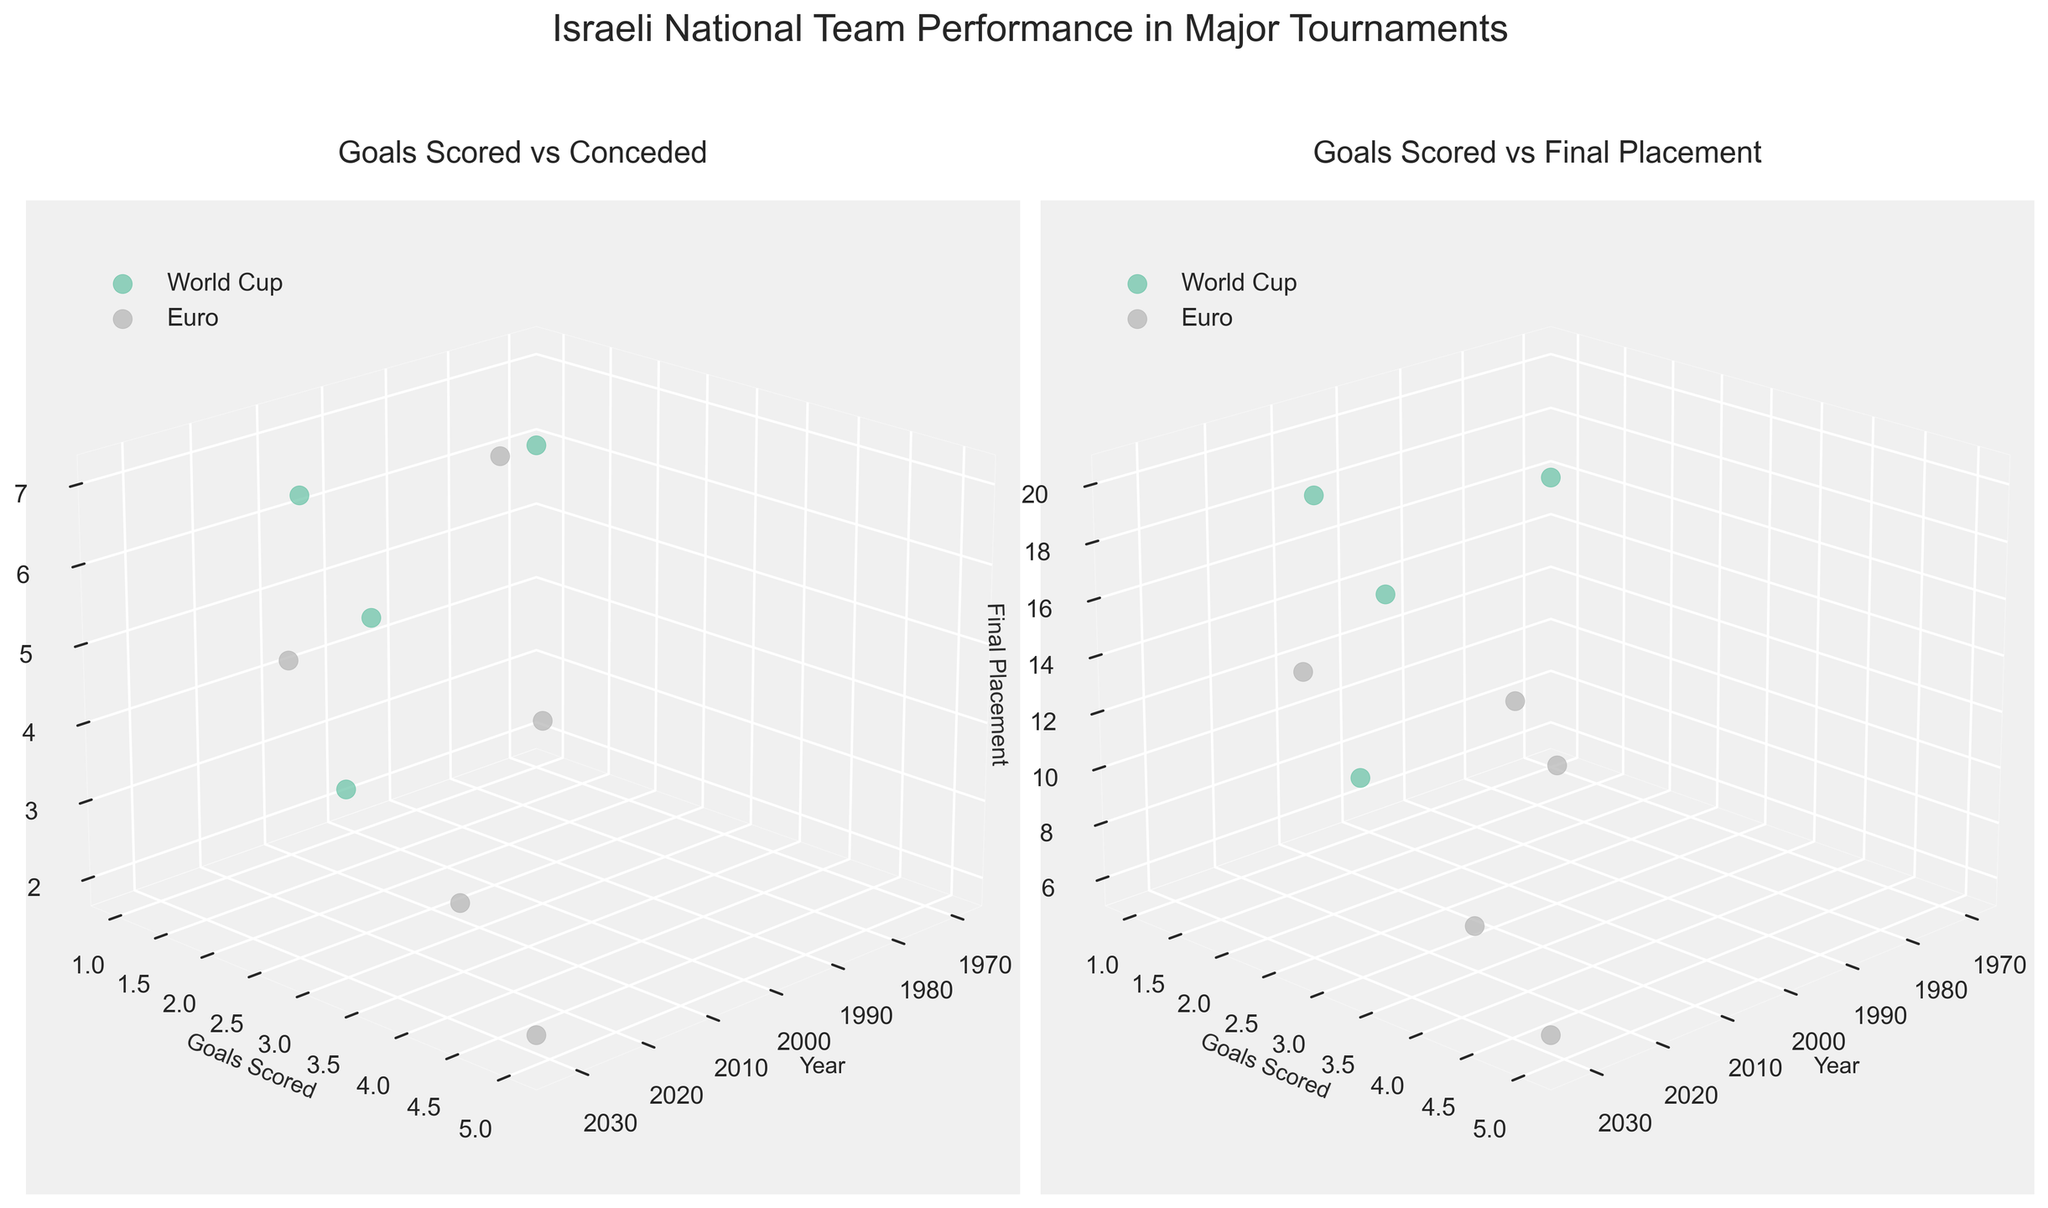What's the title of the figure? The title of the figure is displayed at the top and provides an overview of what the figure represents, which in this case is "Israeli National Team Performance in Major Tournaments".
Answer: "Israeli National Team Performance in Major Tournaments" Which tournament had the lowest number of goals scored in 1970? To find this, look at the scatter plot for both subplots and identify the tournament with data points corresponding to the year 1970. The tournament is labeled "World Cup" with a single data point in 1970 showing 1 goal scored.
Answer: World Cup How many goals did Israel concede in the Euro 2032 tournament according to the left subplot? Identify the data point corresponding to the Euro 2032 on the left 3D plot ("Goals Scored vs Conceded"). The Goals Conceded axis shows that 2 goals were conceded.
Answer: 2 Did Israel score more goals in World Cup 2026 or Euro 2028? Locate the data points for World Cup 2026 and Euro 2028 on either of the 3D scatter plots. Compare the Goals Scored values for these two points. Israel scored 3 goals in World Cup 2026 and 4 goals in Euro 2028, thus more goals were scored in Euro 2028.
Answer: Euro 2028 What's the relationship between final placement and goals scored in the Euro 2032 tournament? Check the data point for Euro 2032 on the right subplot ("Goals Scored vs Final Placement"). Euro 2032 shows a final placement of 6 with 5 goals scored.
Answer: 5 goals scored, 6th final placement In which tournament did Israel have its best final placement among those listed? Find the smallest value on the Final Placement axis in the right subplot ("Goals Scored vs Final Placement"). The lowest value (best placement) is 6, which occurred in Euro 2032.
Answer: Euro 2032 Did Israel's goals scored increase, decrease, or stay the same between Euro 2024 and World Cup 2026? Compare the data points for Euro 2024 and World Cup 2026 on the 3D scatter plots. Goals Scored in Euro 2024 is 2 and in World Cup 2026 is 3, indicating an increase.
Answer: Increased How many total goals did Israel score across all tournaments according to the data? Add up the goals scored from each tournament. 1+1+2+3+2+3+4+3+5 = 24.
Answer: 24 What is the pattern of goals conceded by Israel in World Cup tournaments as per the left subplot? Focus on the data points related to the World Cup tournaments in the left subplot. The values are 6 (1970), 7 (2022), 6 (2026), and 4 (2030). The pattern does not show a clear linear trend but illustrates variability.
Answer: No clear trend, variable Is there any year where Israel scored the same number of goals in both World Cup and Euro tournaments? If so, which year? Check if any year has overlapping data points with the same Goals Scored value in both subplots. In 2030 (World Cup) and 2024 (Euro), Israel scored a different amount. No year shows such overlap in goals scored for both tournament types.
Answer: No 